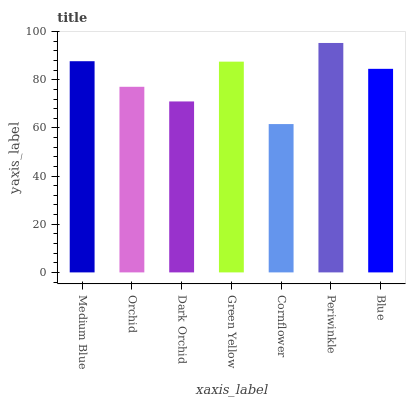Is Cornflower the minimum?
Answer yes or no. Yes. Is Periwinkle the maximum?
Answer yes or no. Yes. Is Orchid the minimum?
Answer yes or no. No. Is Orchid the maximum?
Answer yes or no. No. Is Medium Blue greater than Orchid?
Answer yes or no. Yes. Is Orchid less than Medium Blue?
Answer yes or no. Yes. Is Orchid greater than Medium Blue?
Answer yes or no. No. Is Medium Blue less than Orchid?
Answer yes or no. No. Is Blue the high median?
Answer yes or no. Yes. Is Blue the low median?
Answer yes or no. Yes. Is Periwinkle the high median?
Answer yes or no. No. Is Orchid the low median?
Answer yes or no. No. 